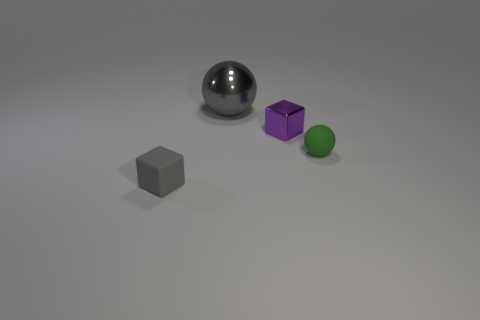Add 4 matte spheres. How many objects exist? 8 Subtract all gray spheres. How many spheres are left? 1 Add 2 tiny green rubber objects. How many tiny green rubber objects exist? 3 Subtract 0 blue balls. How many objects are left? 4 Subtract all green blocks. Subtract all brown balls. How many blocks are left? 2 Subtract all large gray cubes. Subtract all tiny purple metal cubes. How many objects are left? 3 Add 1 large objects. How many large objects are left? 2 